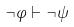Convert formula to latex. <formula><loc_0><loc_0><loc_500><loc_500>\neg \varphi \vdash \neg \psi</formula> 